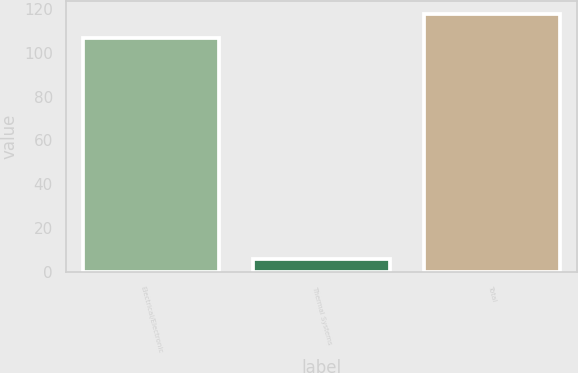<chart> <loc_0><loc_0><loc_500><loc_500><bar_chart><fcel>Electrical/Electronic<fcel>Thermal Systems<fcel>Total<nl><fcel>107<fcel>6<fcel>117.7<nl></chart> 